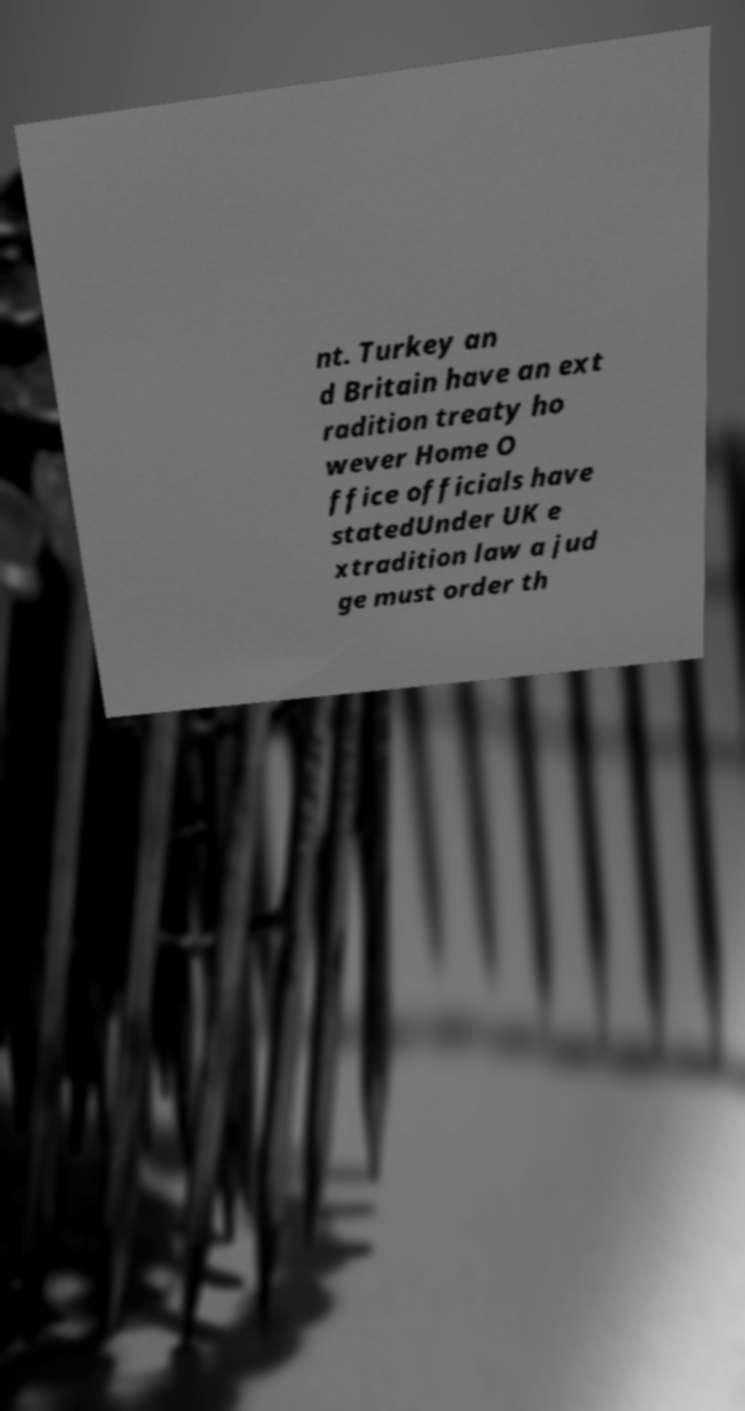Could you assist in decoding the text presented in this image and type it out clearly? nt. Turkey an d Britain have an ext radition treaty ho wever Home O ffice officials have statedUnder UK e xtradition law a jud ge must order th 